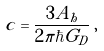<formula> <loc_0><loc_0><loc_500><loc_500>c = \frac { 3 A _ { h } } { 2 \pi \hbar { G } _ { D } } \, ,</formula> 